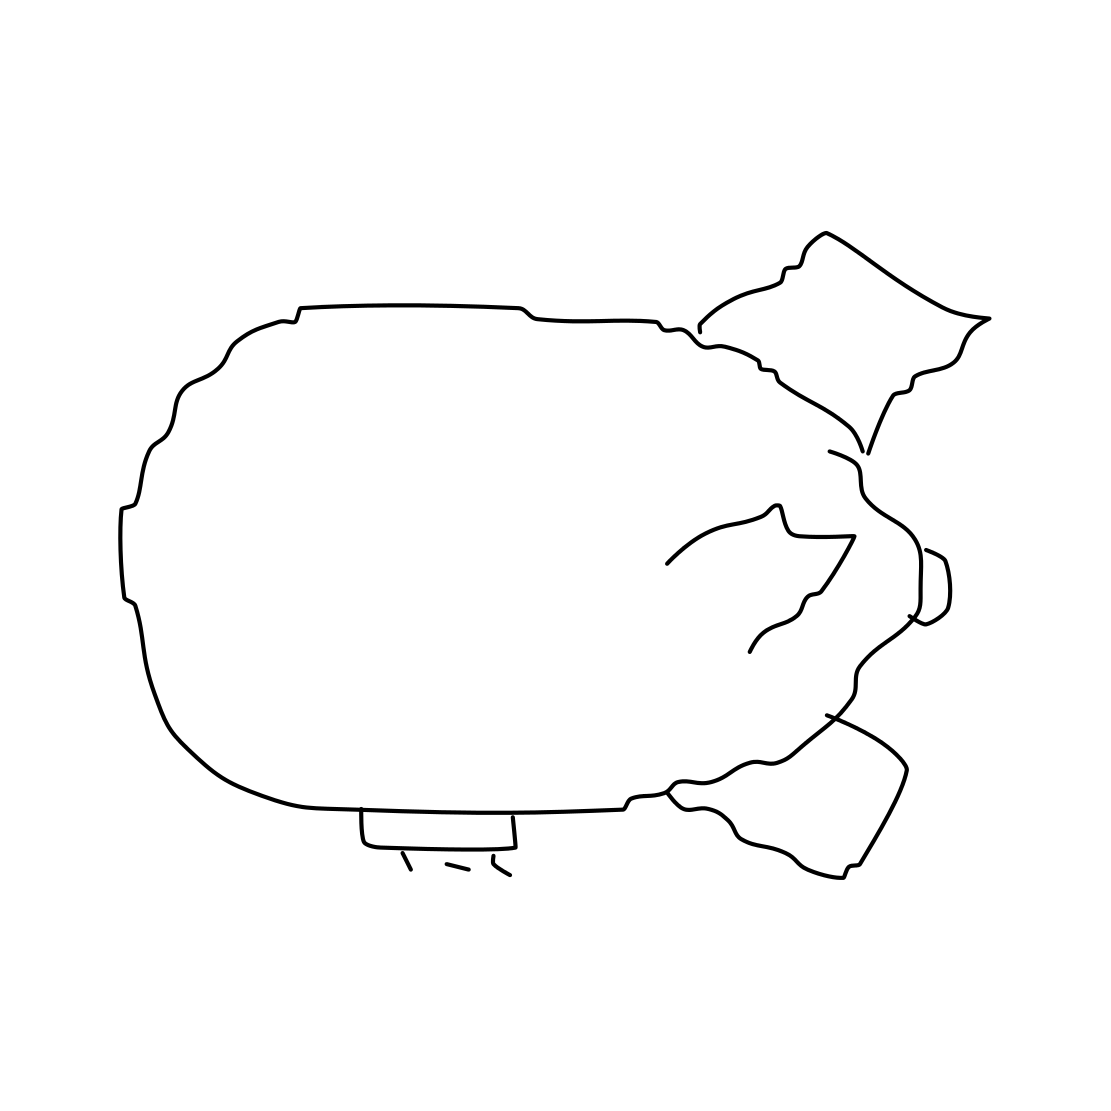Is there a sketchy blimp in the picture? Yes, the image does showcase what appears to be a line drawing of a blimp. It has an elliptical body typically associated with blimps and fins or rudders that suggest it's an airship designed for navigation through the air. 